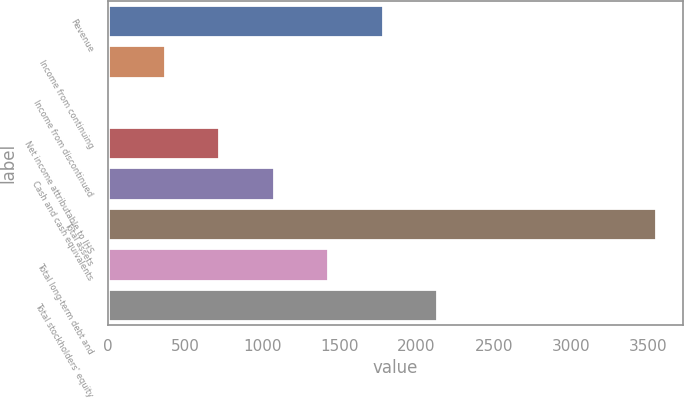<chart> <loc_0><loc_0><loc_500><loc_500><bar_chart><fcel>Revenue<fcel>Income from continuing<fcel>Income from discontinued<fcel>Net income attributable to IHS<fcel>Cash and cash equivalents<fcel>Total assets<fcel>Total long-term debt and<fcel>Total stockholders' equity<nl><fcel>1782<fcel>368.24<fcel>14.8<fcel>721.68<fcel>1075.12<fcel>3549.2<fcel>1428.56<fcel>2135.44<nl></chart> 